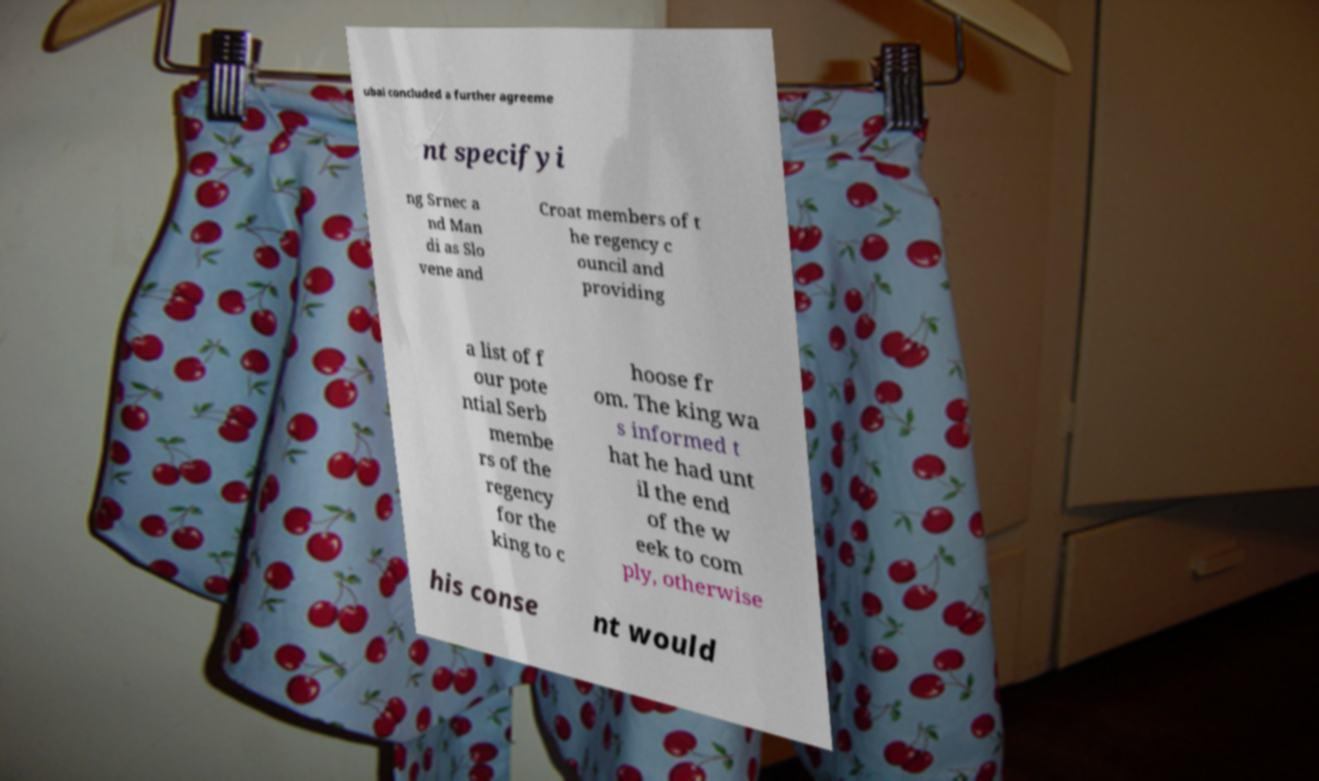Could you assist in decoding the text presented in this image and type it out clearly? ubai concluded a further agreeme nt specifyi ng Srnec a nd Man di as Slo vene and Croat members of t he regency c ouncil and providing a list of f our pote ntial Serb membe rs of the regency for the king to c hoose fr om. The king wa s informed t hat he had unt il the end of the w eek to com ply, otherwise his conse nt would 